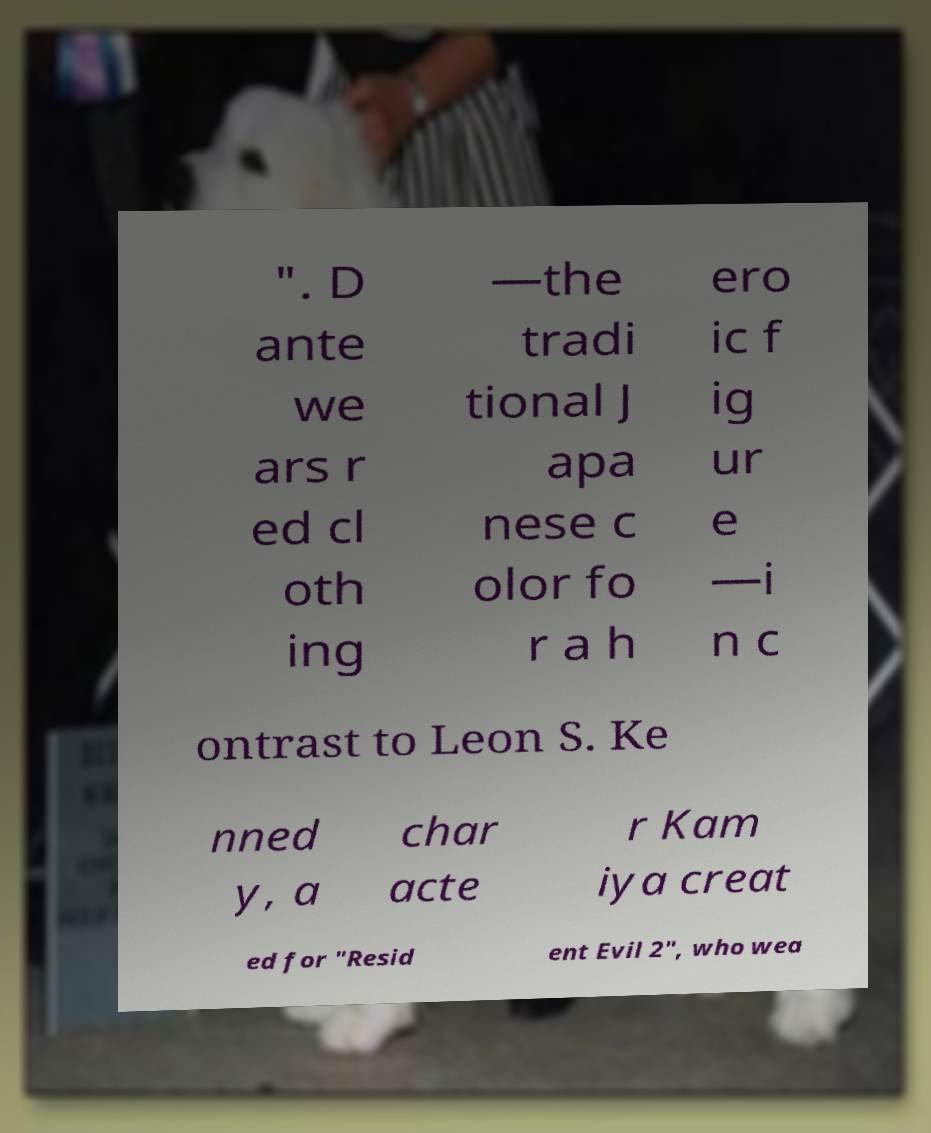I need the written content from this picture converted into text. Can you do that? ". D ante we ars r ed cl oth ing —the tradi tional J apa nese c olor fo r a h ero ic f ig ur e —i n c ontrast to Leon S. Ke nned y, a char acte r Kam iya creat ed for "Resid ent Evil 2", who wea 